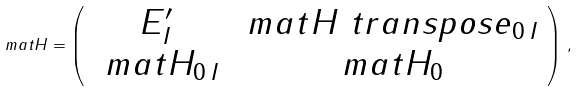Convert formula to latex. <formula><loc_0><loc_0><loc_500><loc_500>\ m a t H = \left ( \begin{array} { c c } E _ { I } ^ { \prime } & \ m a t H \ t r a n s p o s e _ { 0 \, I } \\ \ m a t H _ { 0 \, I } & \ m a t H _ { 0 } \end{array} \right ) \, ,</formula> 